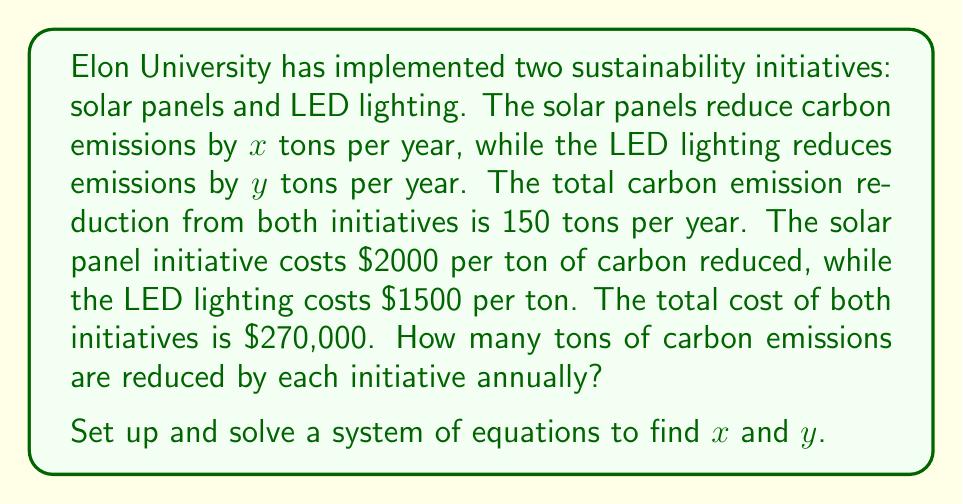Can you solve this math problem? Let's approach this step-by-step:

1) First, let's define our variables:
   $x$ = tons of carbon reduced by solar panels per year
   $y$ = tons of carbon reduced by LED lighting per year

2) Now, we can set up two equations based on the given information:

   Equation 1 (total emission reduction): $x + y = 150$

   Equation 2 (total cost): $2000x + 1500y = 270000$

3) We now have a system of two equations with two unknowns:

   $$\begin{cases}
   x + y = 150 \\
   2000x + 1500y = 270000
   \end{cases}$$

4) Let's solve this system by substitution. From the first equation:
   $x = 150 - y$

5) Substitute this into the second equation:
   $2000(150 - y) + 1500y = 270000$

6) Simplify:
   $300000 - 2000y + 1500y = 270000$
   $300000 - 500y = 270000$

7) Solve for $y$:
   $-500y = -30000$
   $y = 60$

8) Now substitute this value of $y$ back into $x + y = 150$:
   $x + 60 = 150$
   $x = 90$

9) Therefore, solar panels reduce 90 tons of carbon emissions per year, and LED lighting reduces 60 tons per year.
Answer: Solar panels: 90 tons/year; LED lighting: 60 tons/year 